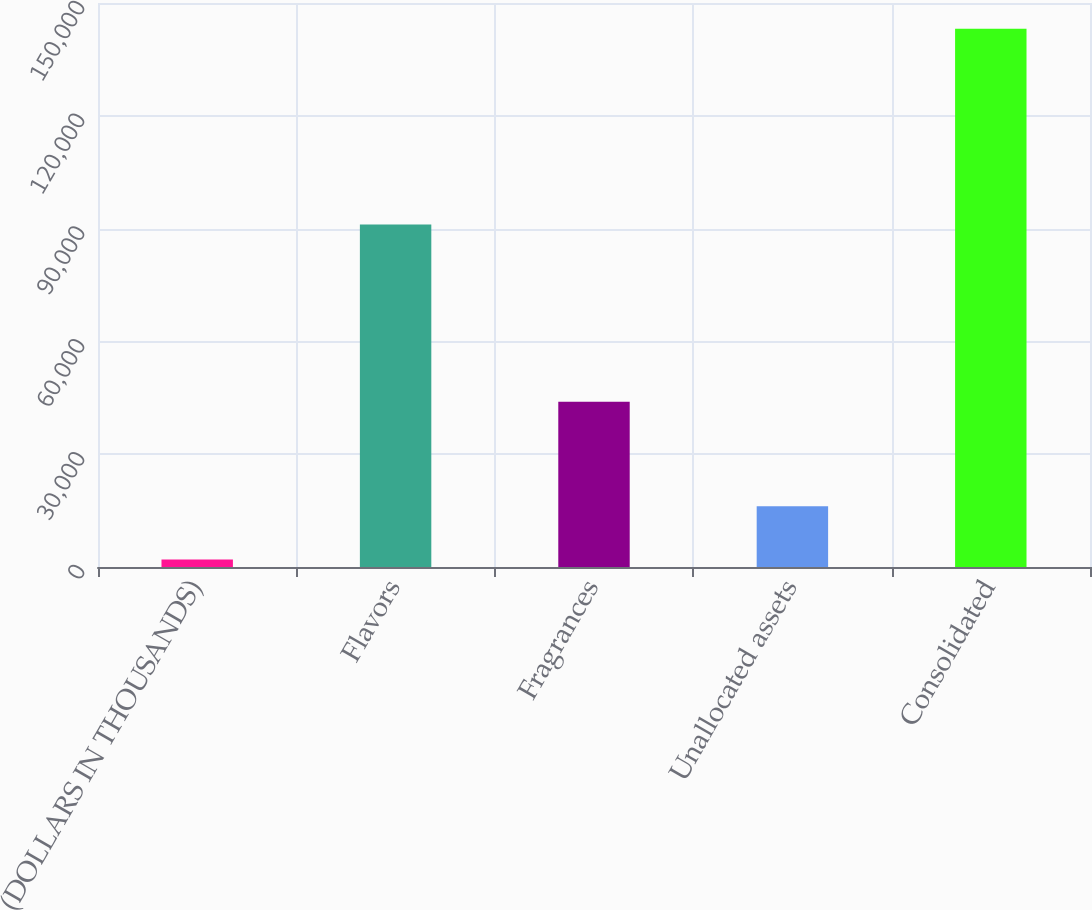Convert chart. <chart><loc_0><loc_0><loc_500><loc_500><bar_chart><fcel>(DOLLARS IN THOUSANDS)<fcel>Flavors<fcel>Fragrances<fcel>Unallocated assets<fcel>Consolidated<nl><fcel>2014<fcel>91104<fcel>43948<fcel>16130.8<fcel>143182<nl></chart> 